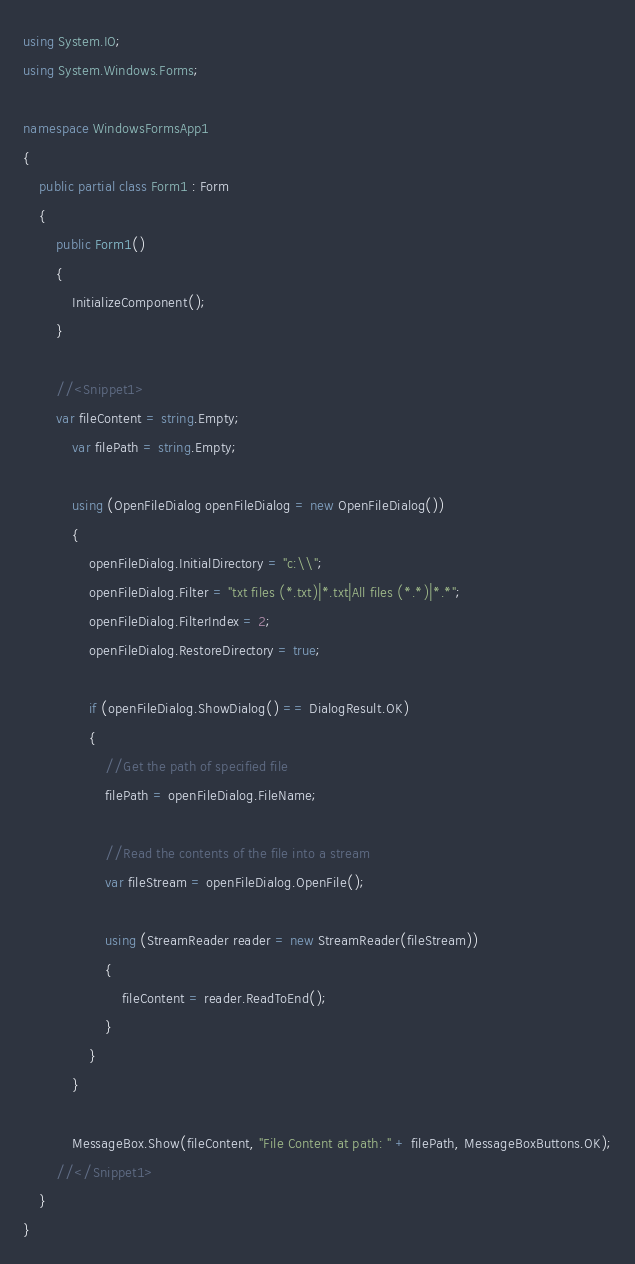<code> <loc_0><loc_0><loc_500><loc_500><_C#_>using System.IO;
using System.Windows.Forms;

namespace WindowsFormsApp1
{
    public partial class Form1 : Form
    {
        public Form1()
        {
            InitializeComponent();
        }

        //<Snippet1>
        var fileContent = string.Empty;
            var filePath = string.Empty;

            using (OpenFileDialog openFileDialog = new OpenFileDialog())
            {
                openFileDialog.InitialDirectory = "c:\\";
                openFileDialog.Filter = "txt files (*.txt)|*.txt|All files (*.*)|*.*";
                openFileDialog.FilterIndex = 2;
                openFileDialog.RestoreDirectory = true;

                if (openFileDialog.ShowDialog() == DialogResult.OK)
                {
                    //Get the path of specified file
                    filePath = openFileDialog.FileName;

                    //Read the contents of the file into a stream
                    var fileStream = openFileDialog.OpenFile();
                    
                    using (StreamReader reader = new StreamReader(fileStream))
                    {
                        fileContent = reader.ReadToEnd();
                    }
                }
            }

            MessageBox.Show(fileContent, "File Content at path: " + filePath, MessageBoxButtons.OK);
        //</Snippet1>
    }
}
</code> 